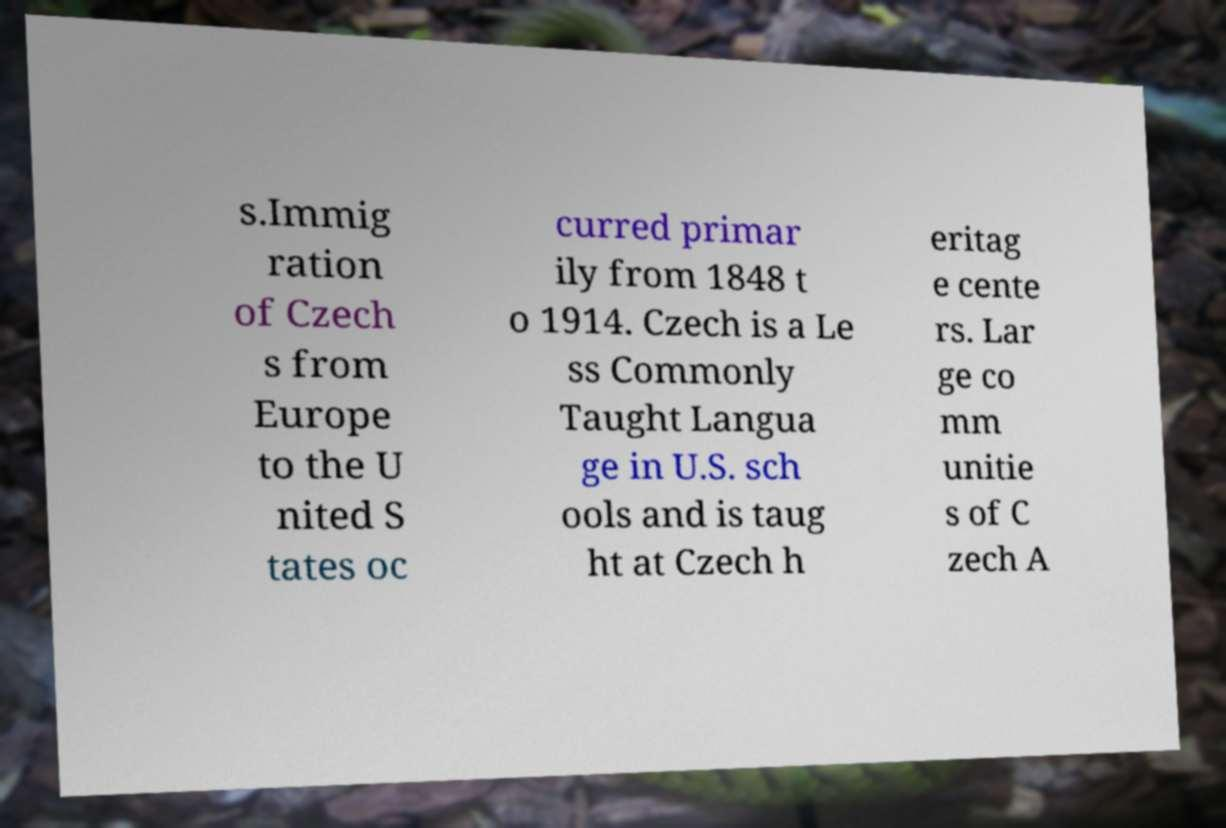What messages or text are displayed in this image? I need them in a readable, typed format. s.Immig ration of Czech s from Europe to the U nited S tates oc curred primar ily from 1848 t o 1914. Czech is a Le ss Commonly Taught Langua ge in U.S. sch ools and is taug ht at Czech h eritag e cente rs. Lar ge co mm unitie s of C zech A 